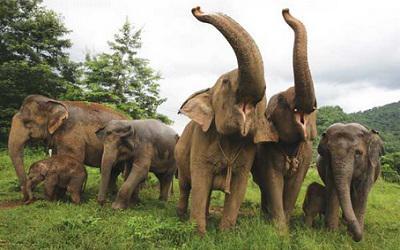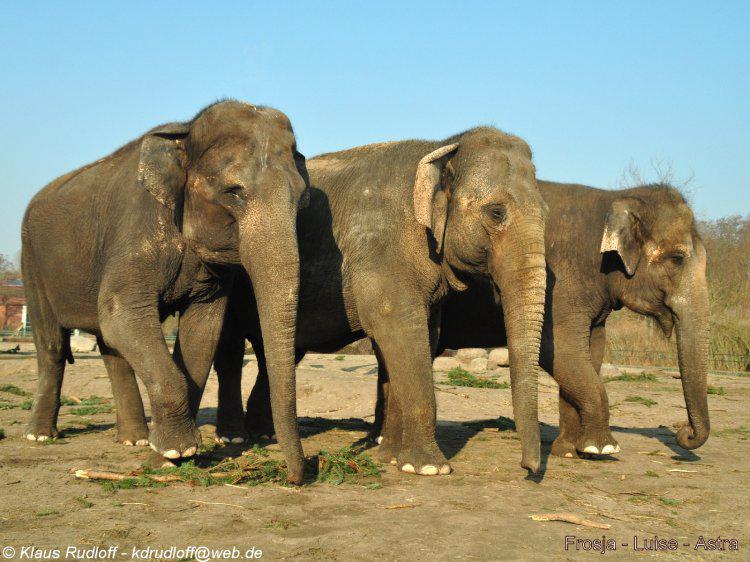The first image is the image on the left, the second image is the image on the right. Given the left and right images, does the statement "There are no more than three elephants in the image on the right." hold true? Answer yes or no. Yes. The first image is the image on the left, the second image is the image on the right. For the images displayed, is the sentence "Elephants are eating pumpkins, another elephant has a baby holding her tail" factually correct? Answer yes or no. No. 